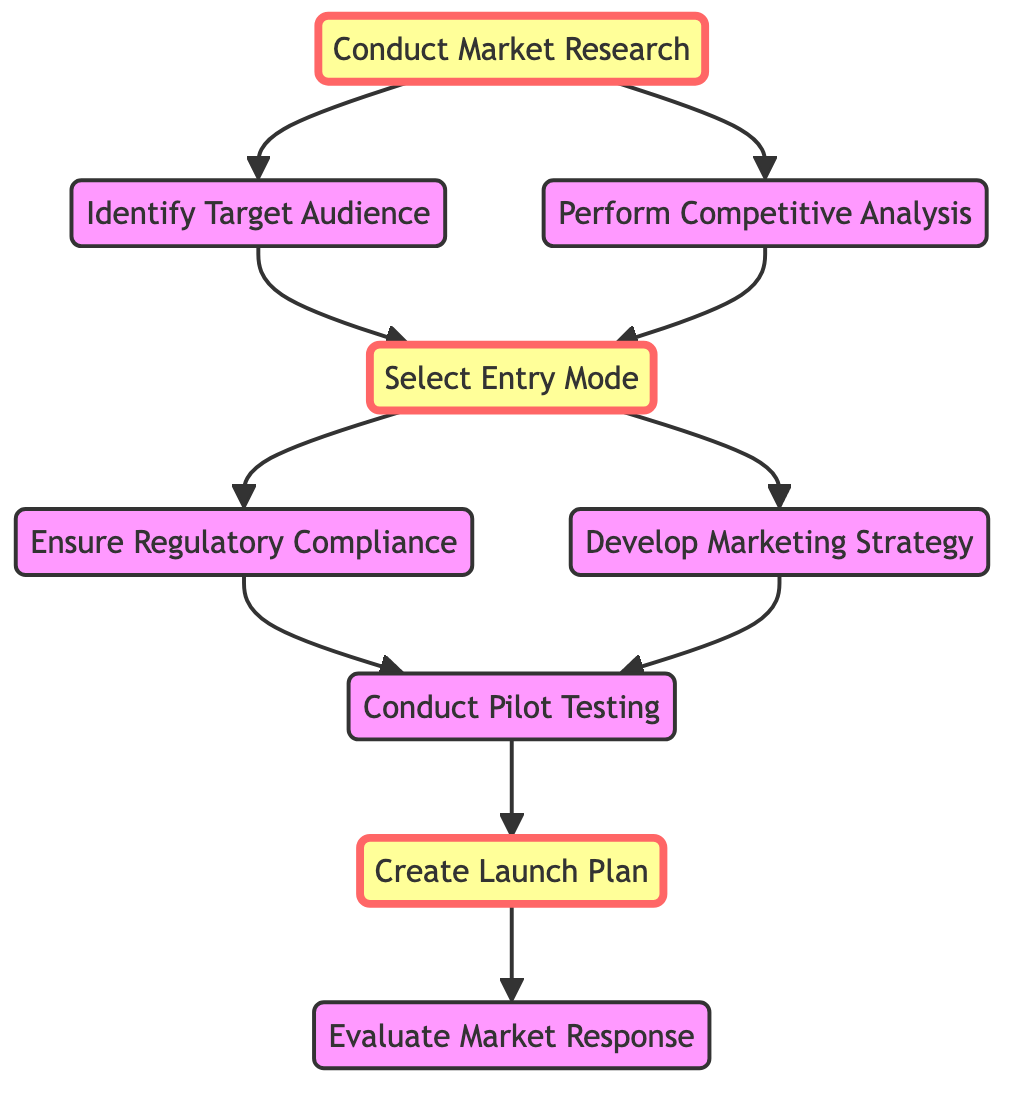What is the first step in the market entry strategy? The first step in the market entry strategy depicted in the diagram is "Conduct Market Research" which is the starting node before any other actions can take place.
Answer: Conduct Market Research How many nodes are present in the diagram? By counting each unique action or decision point listed in the nodes section, I find there are nine distinct nodes in total.
Answer: 9 What follows "Conduct Market Research" in the flowchart? After "Conduct Market Research," the subsequent steps are "Identify Target Audience" and "Perform Competitive Analysis," leading to two different branches of actions.
Answer: Identify Target Audience, Perform Competitive Analysis Which nodes are directly connected to "Select Entry Mode"? "Select Entry Mode" is connected from "Identify Target Audience" and "Perform Competitive Analysis," meaning both of these actions are prerequisites for selecting an entry mode.
Answer: Identify Target Audience, Perform Competitive Analysis What is the final action in the market entry strategy? The final action in this flowchart is "Evaluate Market Response," which follows the "Create Launch Plan" node.
Answer: Evaluate Market Response How many edges are leaving from the "Entry Mode" node? The "Entry Mode" node has two outgoing edges directed towards "Develop Marketing Strategy" and "Ensure Regulatory Compliance," thus there are two edges leading from this node.
Answer: 2 What is the relationship between "Regulatory Compliance" and "Conduct Pilot Testing"? The relationship indicates that "Ensure Regulatory Compliance" must be achieved before "Conduct Pilot Testing," as there is a directed edge from the former to the latter in the diagram.
Answer: Ensure Regulatory Compliance Which node is highlighted in the diagram? The nodes "Conduct Market Research," "Select Entry Mode," and "Create Launch Plan" are highlighted, distinguishing them as key actions in the process.
Answer: Conduct Market Research, Select Entry Mode, Create Launch Plan What action must occur before creating a launch plan? Before creating a launch plan, "Conduct Pilot Testing" must take place as indicated by the directed edge leading to "Create Launch Plan."
Answer: Conduct Pilot Testing 